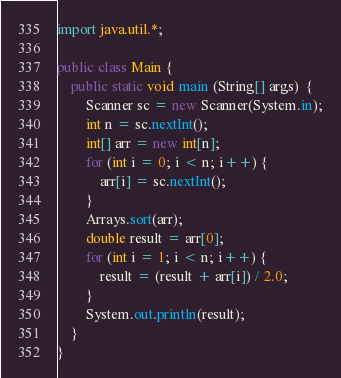Convert code to text. <code><loc_0><loc_0><loc_500><loc_500><_Java_>import java.util.*;

public class Main {
	public static void main (String[] args)  {
		Scanner sc = new Scanner(System.in);
		int n = sc.nextInt();
		int[] arr = new int[n];
		for (int i = 0; i < n; i++) {
			arr[i] = sc.nextInt();
		}
		Arrays.sort(arr);
		double result = arr[0];
		for (int i = 1; i < n; i++) {
			result = (result + arr[i]) / 2.0;
		}
		System.out.println(result);
	}
}
</code> 